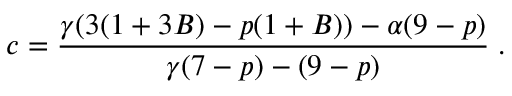Convert formula to latex. <formula><loc_0><loc_0><loc_500><loc_500>c = \frac { \gamma ( 3 ( 1 + 3 B ) - p ( 1 + B ) ) - \alpha ( 9 - p ) } { \gamma ( 7 - p ) - ( 9 - p ) } \, .</formula> 